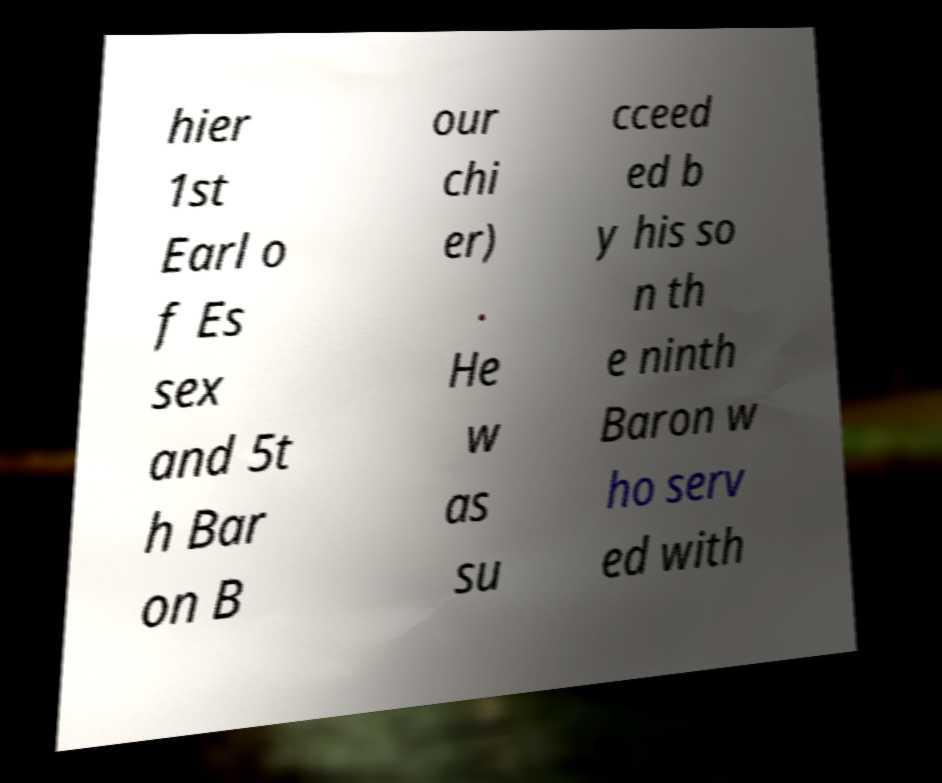Can you accurately transcribe the text from the provided image for me? hier 1st Earl o f Es sex and 5t h Bar on B our chi er) . He w as su cceed ed b y his so n th e ninth Baron w ho serv ed with 